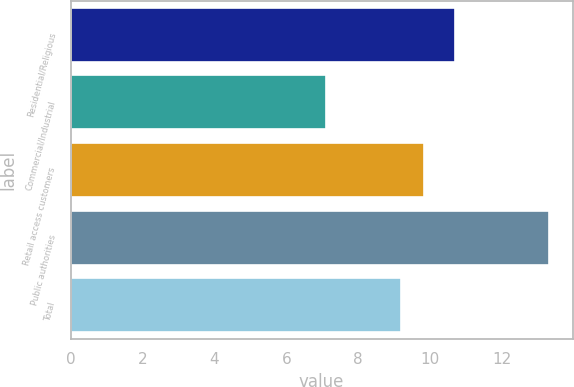<chart> <loc_0><loc_0><loc_500><loc_500><bar_chart><fcel>Residential/Religious<fcel>Commercial/Industrial<fcel>Retail access customers<fcel>Public authorities<fcel>Total<nl><fcel>10.7<fcel>7.1<fcel>9.82<fcel>13.3<fcel>9.2<nl></chart> 